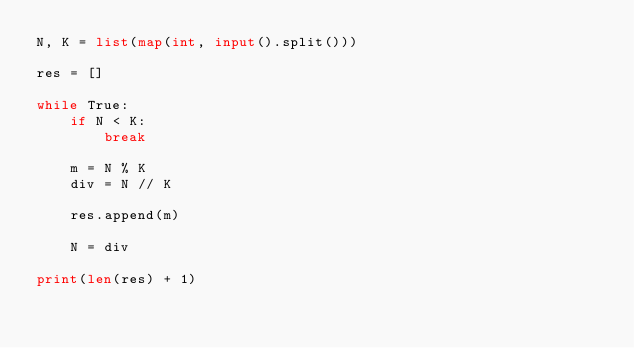<code> <loc_0><loc_0><loc_500><loc_500><_Python_>N, K = list(map(int, input().split()))

res = []

while True:
    if N < K:
        break

    m = N % K
    div = N // K

    res.append(m)

    N = div

print(len(res) + 1)</code> 